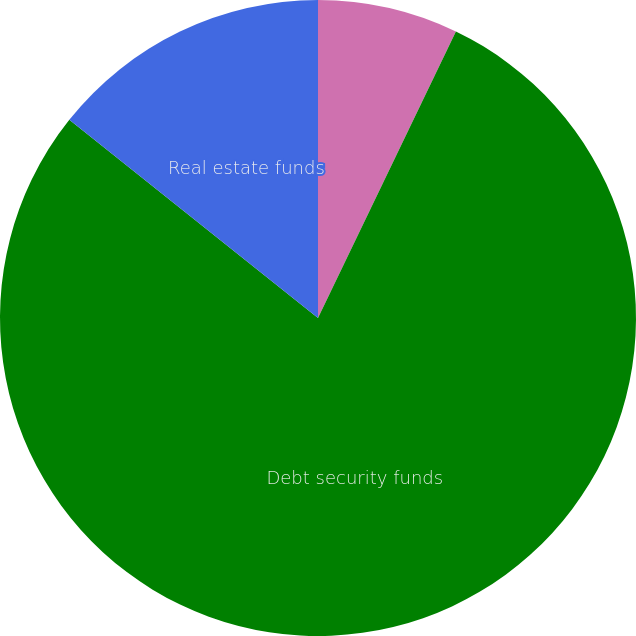Convert chart to OTSL. <chart><loc_0><loc_0><loc_500><loc_500><pie_chart><fcel>Equity security funds<fcel>Debt security funds<fcel>Real estate funds<nl><fcel>7.14%<fcel>78.57%<fcel>14.29%<nl></chart> 